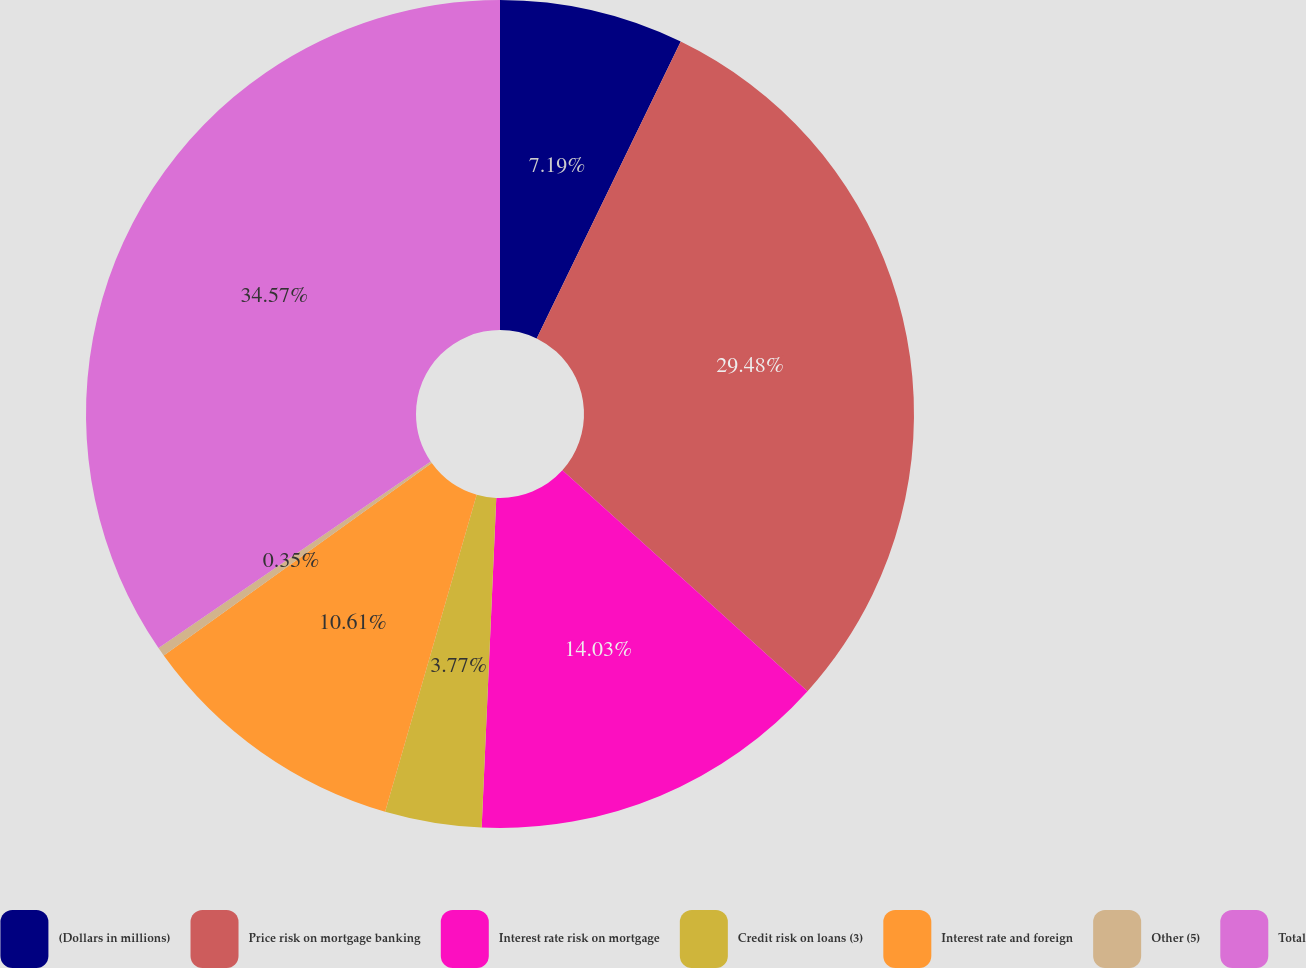Convert chart to OTSL. <chart><loc_0><loc_0><loc_500><loc_500><pie_chart><fcel>(Dollars in millions)<fcel>Price risk on mortgage banking<fcel>Interest rate risk on mortgage<fcel>Credit risk on loans (3)<fcel>Interest rate and foreign<fcel>Other (5)<fcel>Total<nl><fcel>7.19%<fcel>29.48%<fcel>14.03%<fcel>3.77%<fcel>10.61%<fcel>0.35%<fcel>34.56%<nl></chart> 